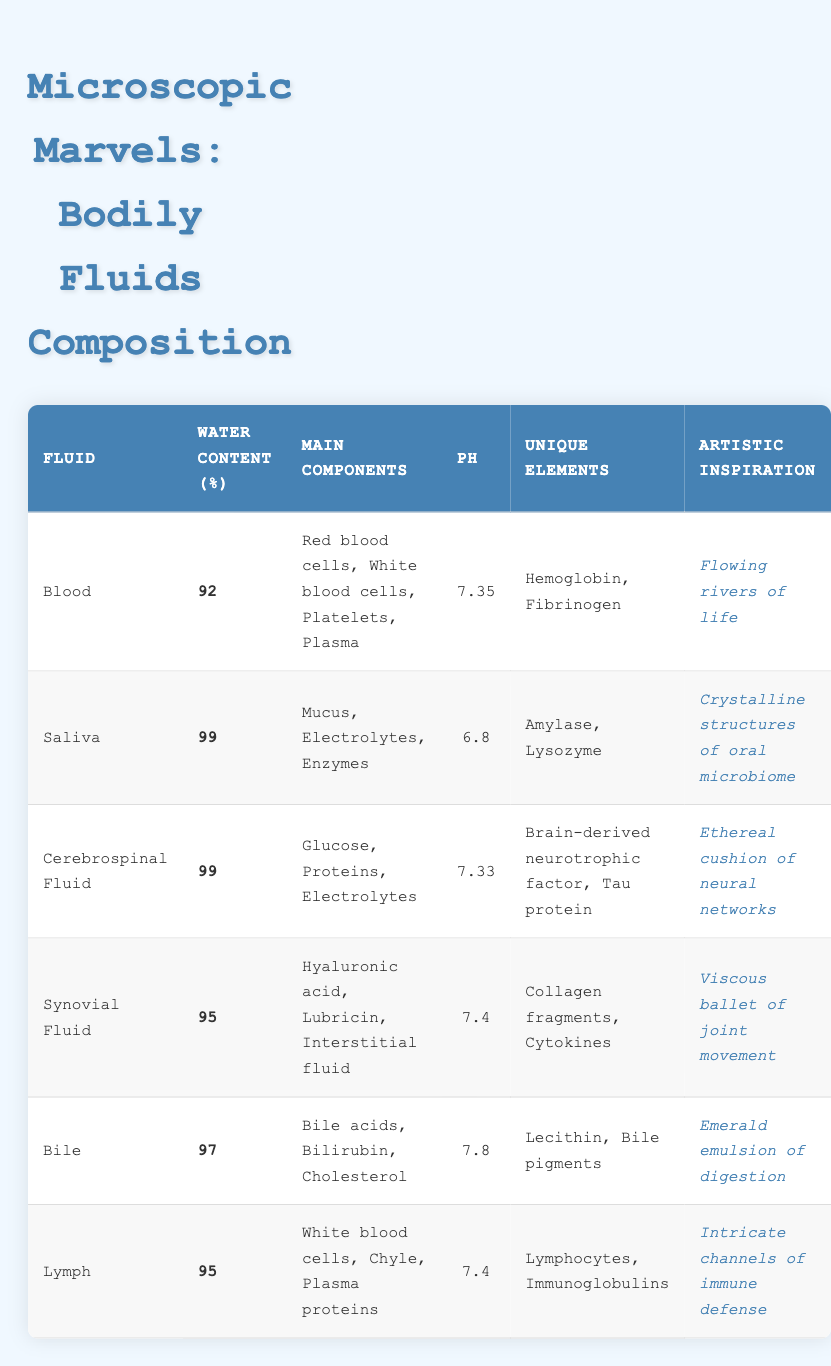What is the water content percentage of saliva? The table shows the water content for each bodily fluid. For saliva, the specified value is directly listed as 99%.
Answer: 99 Which fluid has the lowest pH value? The pH values for each bodily fluid are provided in the table. By comparing them, blood with a pH of 7.35 is determined to have the lowest pH value.
Answer: Blood How many main components does cerebrospinal fluid have? The table lists the main components for cerebrospinal fluid as glucose, proteins, and electrolytes. Counting these, there are 3 main components.
Answer: 3 Is the unique element "Hemoglobin" found in saliva? The table indicates that "Hemoglobin" is a unique element in blood and does not list it in the saliva section. Therefore, it is not found in saliva.
Answer: No Which fluid has the highest water content, and what is that value? The water content values listed for each fluid are compared. Both saliva and cerebrospinal fluid have the highest value of 99%.
Answer: Saliva, 99 What are the unique elements present in synovial fluid? The table specifies "Collagen fragments" and "Cytokines" as the unique elements for synovial fluid, which can be found in the corresponding section.
Answer: Collagen fragments, Cytokines Calculate the average pH of blood and bile. The pH values of blood (7.35) and bile (7.8) are summed to get 15.15, and then divided by 2 to find the average: 15.15 / 2 = 7.575.
Answer: 7.575 Which two fluids contain white blood cells as a main component? By checking the main components listed, it is found that both blood and lymph contain white blood cells.
Answer: Blood, Lymph What is the artistic inspiration derived from cerebrospinal fluid? The table includes a column for artistic inspiration, stating that the inspiration from cerebrospinal fluid is "Ethereal cushion of neural networks."
Answer: Ethereal cushion of neural networks 